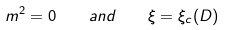Convert formula to latex. <formula><loc_0><loc_0><loc_500><loc_500>m ^ { 2 } = 0 \quad a n d \quad \xi = \xi _ { c } ( D )</formula> 